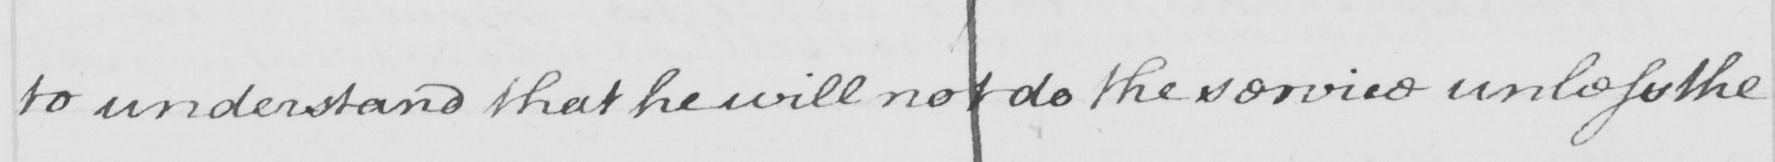Can you tell me what this handwritten text says? to understand that he will not do the service unless the 